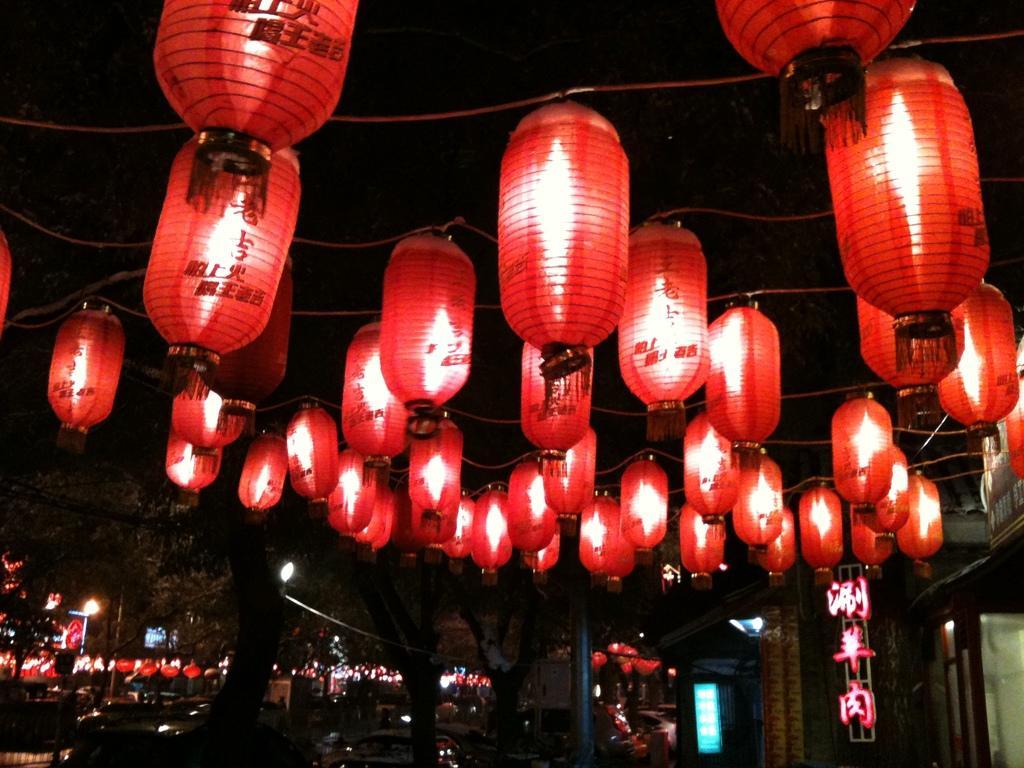How would you summarize this image in a sentence or two? In this picture we can see there are decorative lights which are hanged to the wires. Behind the lights there is a board, trees and some vehicles on the path. 